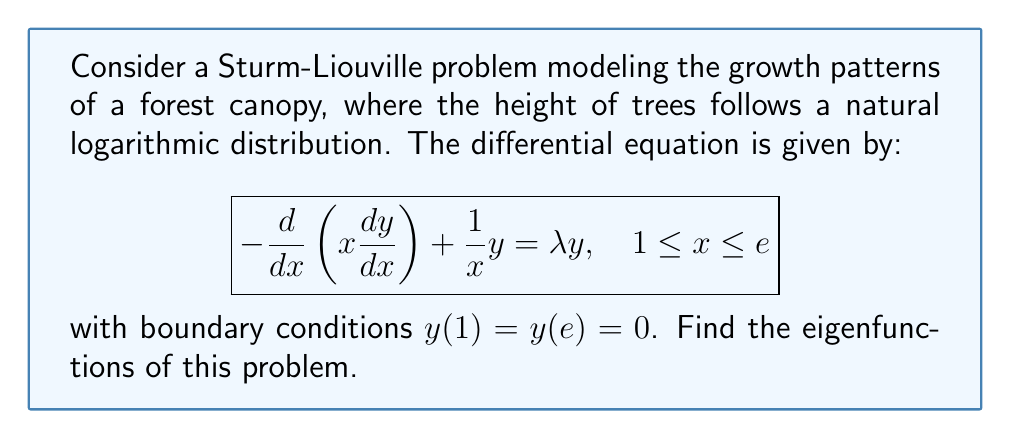Show me your answer to this math problem. To solve this Sturm-Liouville problem, we follow these steps:

1) First, we rewrite the equation in standard Sturm-Liouville form:
   $$-\frac{d}{dx}\left(p(x)\frac{dy}{dx}\right) + q(x)y = \lambda w(x)y$$
   Here, $p(x) = x$, $q(x) = \frac{1}{x}$, and $w(x) = 1$.

2) We make the substitution $z = \ln x$, which transforms the domain to $0 \leq z \leq 1$.

3) Under this substitution, we get:
   $$\frac{d^2y}{dz^2} + (\lambda - 1)y = 0$$

4) This is a standard second-order differential equation with general solution:
   $$y(z) = A\cos(\sqrt{\lambda - 1}z) + B\sin(\sqrt{\lambda - 1}z)$$

5) Applying the boundary conditions:
   $y(0) = 0$ implies $A = 0$
   $y(1) = 0$ implies $B\sin(\sqrt{\lambda - 1}) = 0$

6) For non-trivial solutions, we must have $\sin(\sqrt{\lambda - 1}) = 0$, which occurs when:
   $$\sqrt{\lambda - 1} = n\pi, \quad n = 1, 2, 3, ...$$

7) Solving for $\lambda$:
   $$\lambda_n = (n\pi)^2 + 1, \quad n = 1, 2, 3, ...$$

8) The corresponding eigenfunctions are:
   $$y_n(z) = \sin(n\pi z), \quad n = 1, 2, 3, ...$$

9) Transforming back to the original variable $x$:
   $$y_n(x) = \sin(n\pi \ln x), \quad n = 1, 2, 3, ...$$
Answer: $y_n(x) = \sin(n\pi \ln x)$, $n = 1, 2, 3, ...$ 